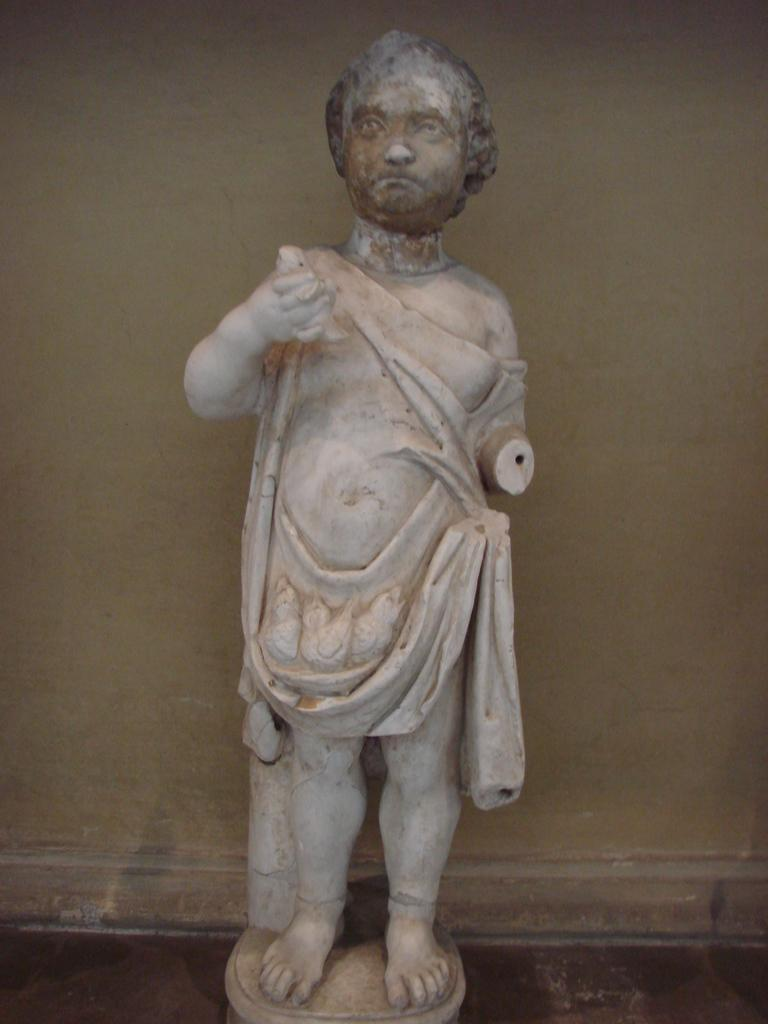What is the main subject in the image? There is a statue in the image. Where is the statue located? The statue is on the floor. What else can be seen in the image besides the statue? There is a wall visible in the image. What type of throat-soothing liquid can be seen near the statue in the image? There is no throat-soothing liquid or any reference to a throat in the image; it only features a statue on the floor and a wall. 